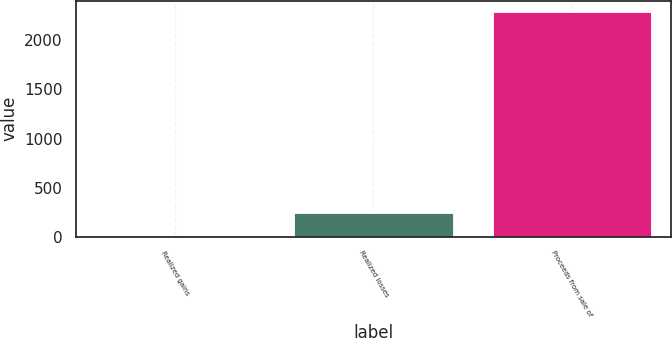Convert chart to OTSL. <chart><loc_0><loc_0><loc_500><loc_500><bar_chart><fcel>Realized gains<fcel>Realized losses<fcel>Proceeds from sale of<nl><fcel>9<fcel>237.1<fcel>2290<nl></chart> 